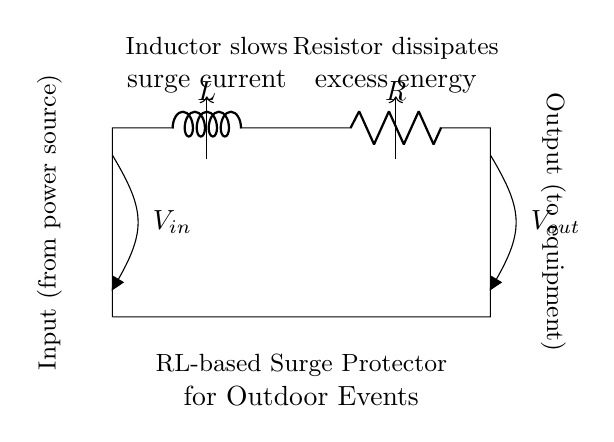What are the components of this circuit? The circuit consists of an inductor labeled L and a resistor labeled R, which are connected in series.
Answer: Inductor and Resistor What is the function of the inductor in this circuit? The inductor's role is to slow down surge current, which prevents abrupt changes in current that could damage sensitive electronics.
Answer: Slow down surge current What does the resistor do in this circuit? The resistor dissipates excess energy, translating surge power into heat, thereby protecting the connected equipment.
Answer: Dissipates excess energy What is the relationship between the input and output in this circuit? The input voltage, V_in, supplies power to the circuit, while V_out delivers a regulated output voltage to the connected equipment, ensuring that the devices receive safe voltage levels.
Answer: Regulated output voltage How does this RL-based surge protector safeguard equipment? By utilizing the characteristics of the inductor and resistor, it absorbs sudden voltage spikes and dissipates energy, which decreases the likelihood of damage to connected devices.
Answer: Absorbs voltage spikes What could be a consequence of removing the inductor from this circuit? Without the inductor, the circuit would not effectively limit the surge current, leading to potential damage from high current surges reaching the equipment.
Answer: Potential damage to equipment 